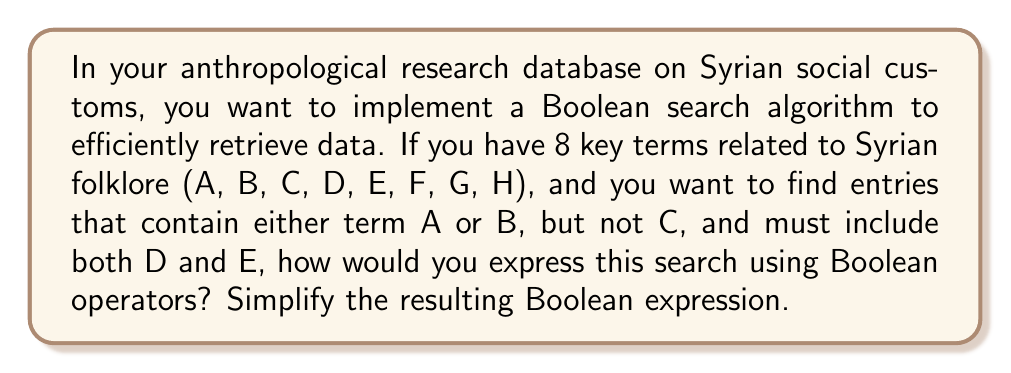Can you answer this question? Let's approach this step-by-step:

1) First, let's translate the search requirements into Boolean logic:
   - Entries containing A or B: $(A \lor B)$
   - Not containing C: $(\lnot C)$
   - Must include both D and E: $(D \land E)$

2) Combining these conditions with AND operator:
   $$(A \lor B) \land (\lnot C) \land (D \land E)$$

3) This expression can be simplified using the distributive property and the associative property of Boolean algebra:
   $((A \lor B) \land \lnot C) \land (D \land E)$

4) The expression $(D \land E)$ cannot be simplified further.

5) Therefore, our final simplified Boolean expression is:
   $((A \lor B) \land \lnot C) \land (D \land E)$

This Boolean expression will efficiently retrieve entries from your anthropological research database that contain either term A or B (or both), do not contain C, and must include both D and E.
Answer: $((A \lor B) \land \lnot C) \land (D \land E)$ 